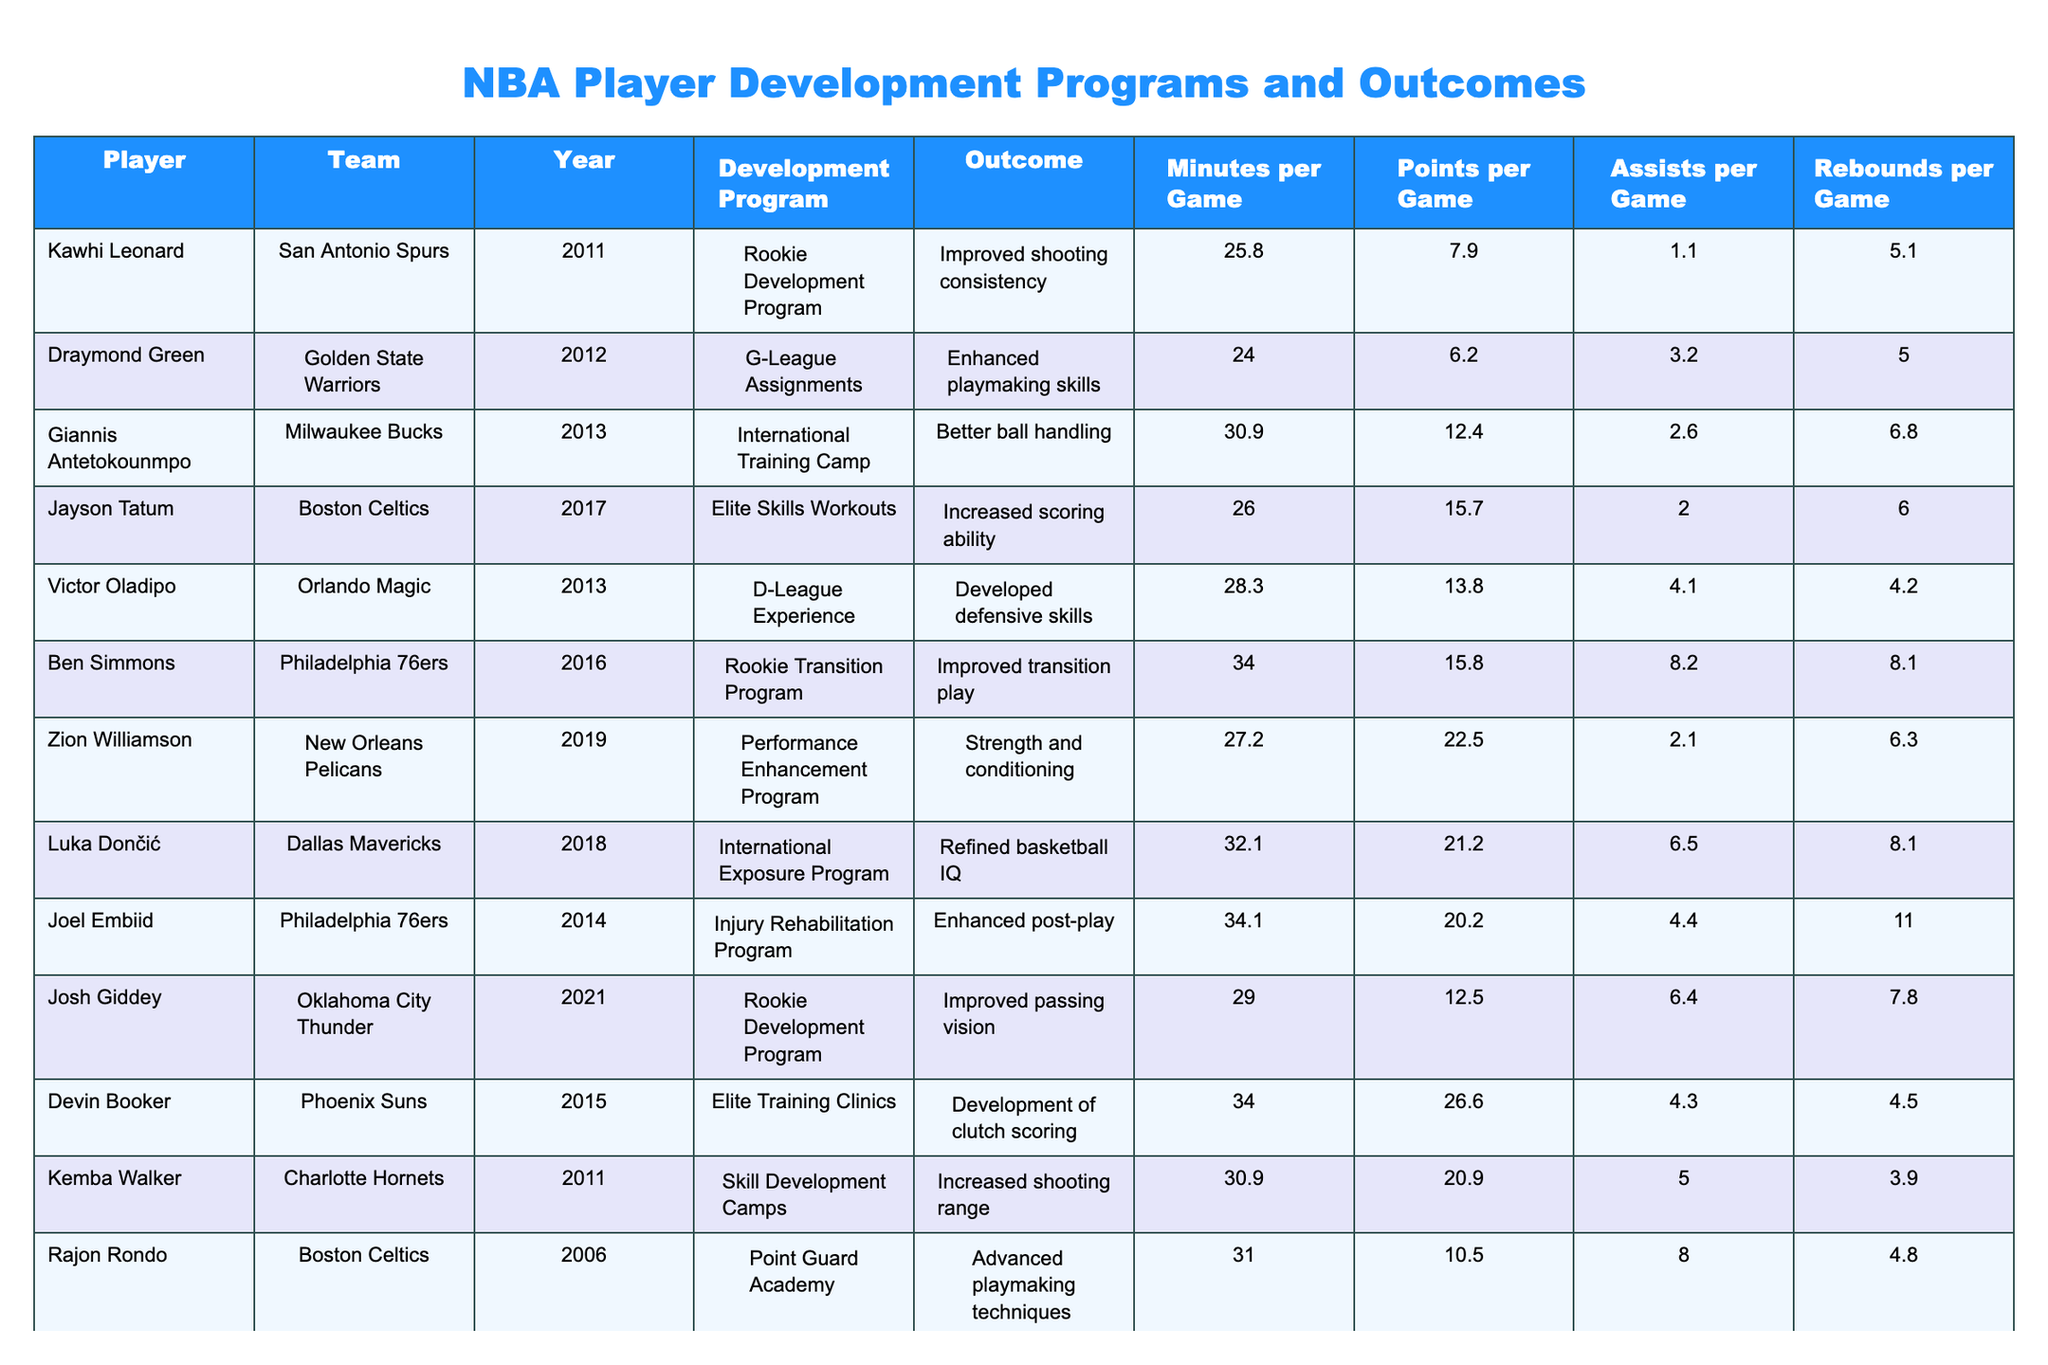What outcome did Kawhi Leonard achieve in his development program? The table indicates that in 2011, Kawhi Leonard participated in the Rookie Development Program, which resulted in improved shooting consistency.
Answer: Improved shooting consistency Which player showed an increase in points per game after undergoing the International Exposure Program? Luka Dončić participated in the International Exposure Program and achieved 21.2 points per game, as shown in the table.
Answer: Luka Dončić What is the average number of assists per game for players in the Rookie Development Program? The players in the Rookie Development Program are Kawhi Leonard (1.1), Ben Simmons (8.2), and Josh Giddey (6.4). The total assists per game is 1.1 + 8.2 + 6.4 = 15.7, and there are 3 players, so the average is 15.7 / 3 = 5.23.
Answer: 5.23 Did any players improve their rebounding abilities as a direct outcome of their development programs? Looking at the outcomes listed for each player, none specifically mention improving rebounding skills; thus, the answer is no.
Answer: No Which two players had the highest minutes per game in the dataset, and what were their outcomes? The players with the highest minutes per game are Ben Simmons with 34.0 minutes, improving transition play, and Joel Embiid with 34.1 minutes, enhancing post-play. Both were noted as having significant outcomes from their programs.
Answer: Ben Simmons (improved transition play), Joel Embiid (enhanced post-play) How many players participated in G-League assignments, and what is their average points per game? The players who participated in G-League assignments are Draymond Green (6.2 points) and Mason Plumlee (7.9 points), totaling 14.1 points. With 2 players, the average is 14.1 / 2 = 7.05.
Answer: 2 players, average 7.05 points per game What was the highest points per game recorded by any player, and which player was it? Devin Booker achieved the highest points per game recorded in the dataset with 26.6 points from Elite Training Clinics, based on the table's information.
Answer: 26.6 points per game, Devin Booker Did Victor Oladipo's participation in his program correlate with an improvement in assists per game? Victor Oladipo had 4.1 assists per game after participating in the D-League Experience, but without prior data for comparison, one cannot definitively state improvement based only on this table.
Answer: Not determinable 